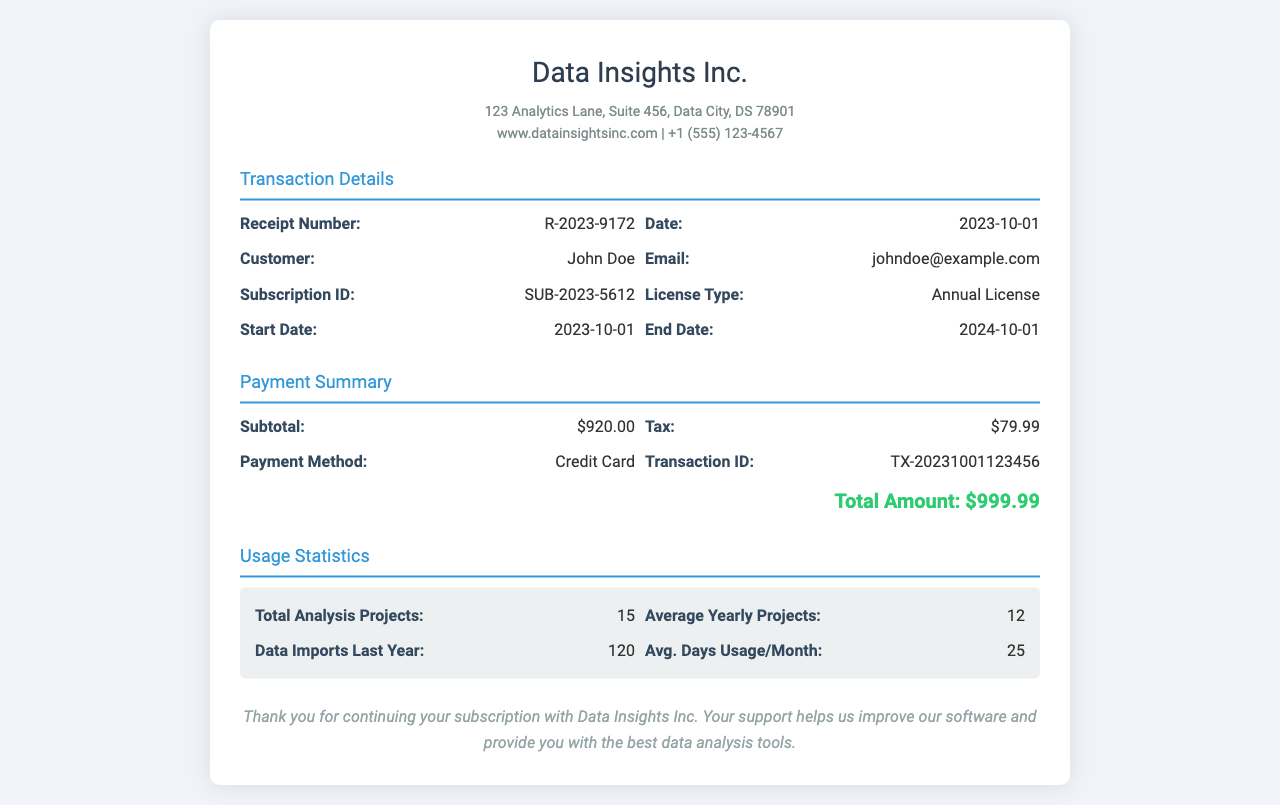What is the receipt number? The receipt number is displayed in the transaction details section for easy reference.
Answer: R-2023-9172 What is the total amount paid? The total amount paid is found in the payment summary section that includes calculations of subtotal, tax, and payment method.
Answer: $999.99 Who is the customer? The customer's name is listed in the transaction details section, capturing the individual's personal information.
Answer: John Doe When does the subscription end? The end date is provided in the subscription details, indicating the duration of the license.
Answer: 2024-10-01 What payment method was used? The payment method is specified in the payment summary, indicating how the transaction was processed.
Answer: Credit Card How many total analysis projects were recorded? The total analysis projects are summarized in the usage statistics, showcasing the customer's engagement with the software.
Answer: 15 What is the average days of usage per month? The average usage is displayed in the usage statistics and reflects the customer's consistent access to the software.
Answer: 25 What is the tax amount? The tax amount is detailed in the payment summary, which is important for financial records.
Answer: $79.99 What is the subscription ID? The subscription ID is provided in the transaction details to uniquely identify the user's subscription.
Answer: SUB-2023-5612 